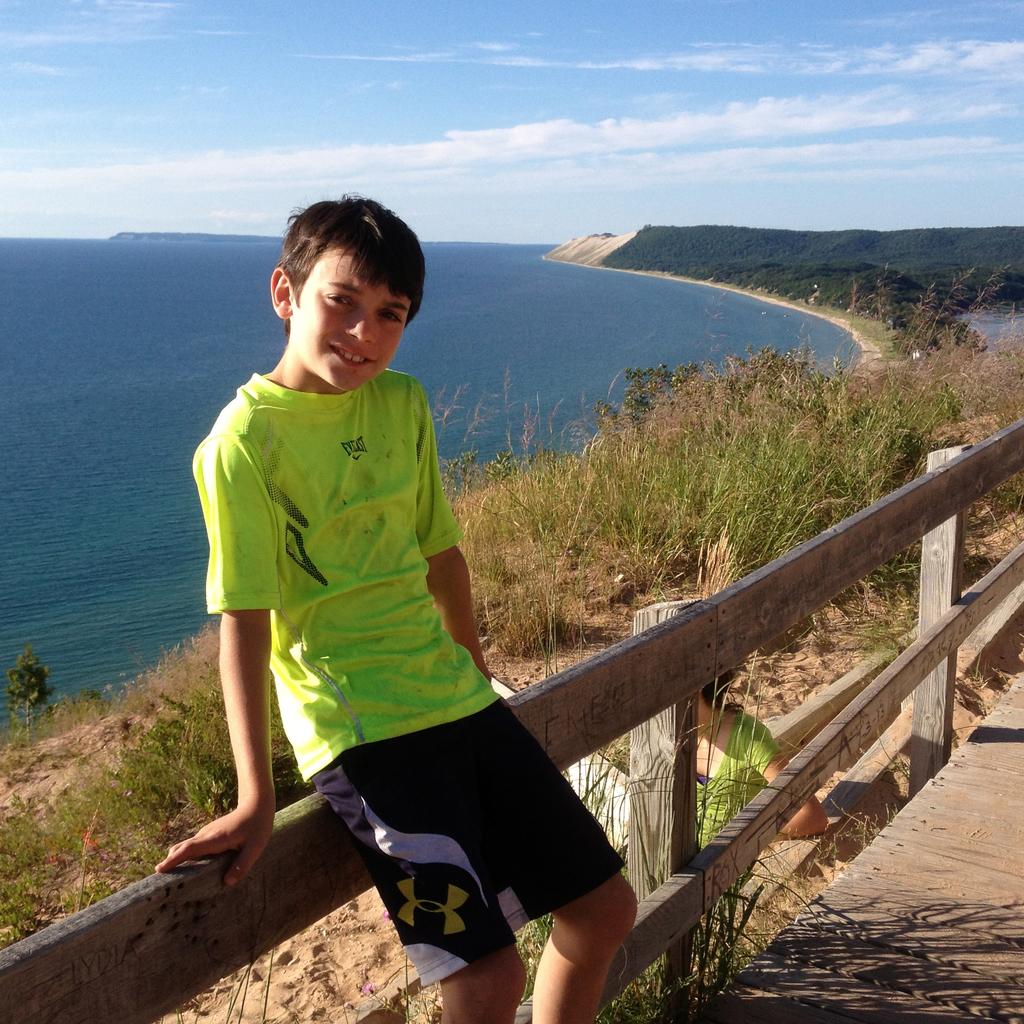What brand are his shorts?
Your response must be concise. Under armour. 